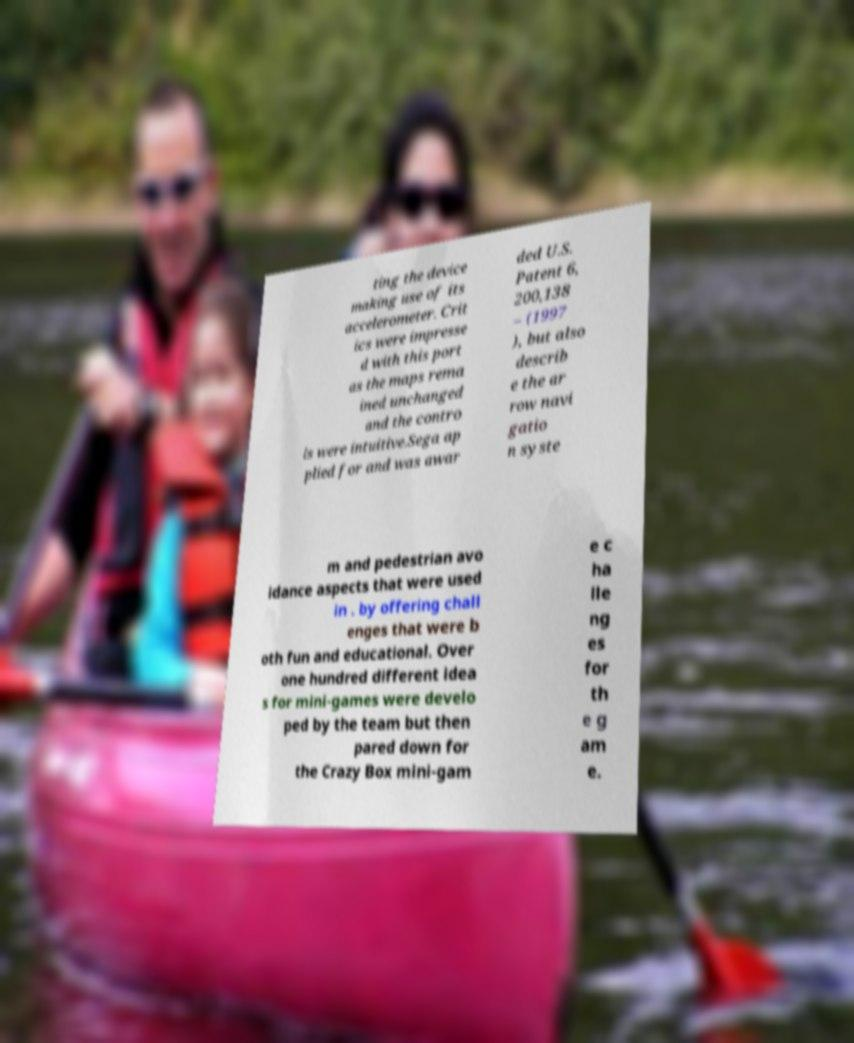There's text embedded in this image that I need extracted. Can you transcribe it verbatim? ting the device making use of its accelerometer. Crit ics were impresse d with this port as the maps rema ined unchanged and the contro ls were intuitive.Sega ap plied for and was awar ded U.S. Patent 6, 200,138 – (1997 ), but also describ e the ar row navi gatio n syste m and pedestrian avo idance aspects that were used in . by offering chall enges that were b oth fun and educational. Over one hundred different idea s for mini-games were develo ped by the team but then pared down for the Crazy Box mini-gam e c ha lle ng es for th e g am e. 